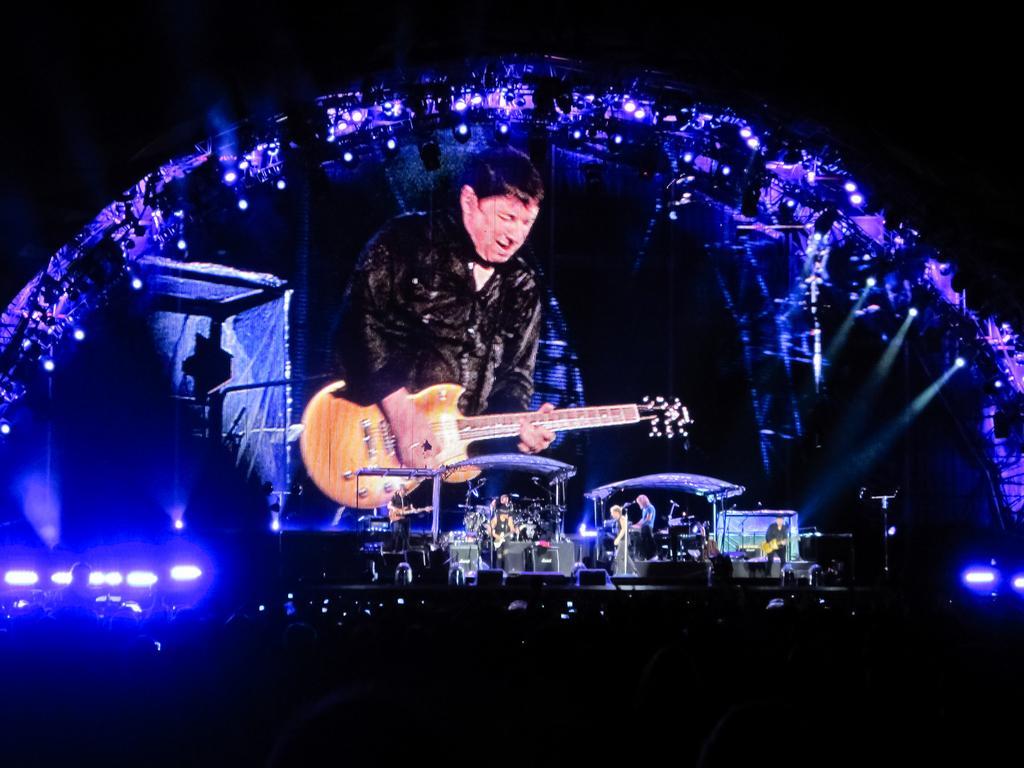Could you give a brief overview of what you see in this image? In the foreground of this image, there is the dark bottom with few lights. In the middle, there are persons on the stage holding musical instruments, a screen, few purple lights and the dark background. 